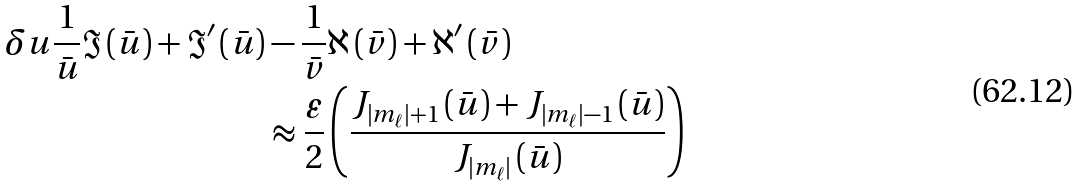<formula> <loc_0><loc_0><loc_500><loc_500>\delta u \frac { 1 } { \bar { u } } \Im \left ( \bar { u } \right ) + \Im ^ { \prime } \left ( \bar { u } \right ) & - \frac { 1 } { \bar { v } } \aleph \left ( \bar { v } \right ) + \aleph ^ { \prime } \left ( \bar { v } \right ) \\ & \approx \frac { \varepsilon } { 2 } \left ( \frac { J _ { \left | m _ { \ell } \right | + 1 } \left ( \bar { u } \right ) + J _ { \left | m _ { \ell } \right | - 1 } \left ( \bar { u } \right ) } { J _ { \left | m _ { \ell } \right | } \left ( \bar { u } \right ) } \right )</formula> 